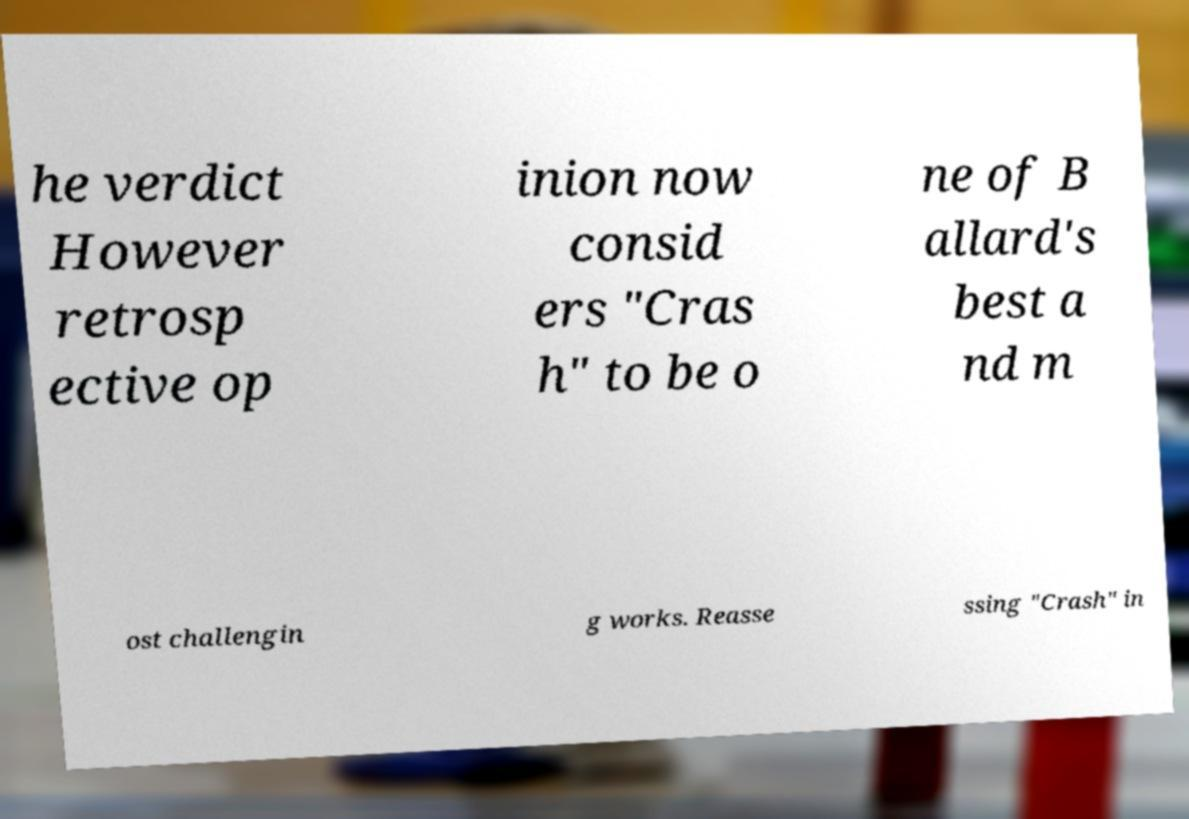Could you assist in decoding the text presented in this image and type it out clearly? he verdict However retrosp ective op inion now consid ers "Cras h" to be o ne of B allard's best a nd m ost challengin g works. Reasse ssing "Crash" in 